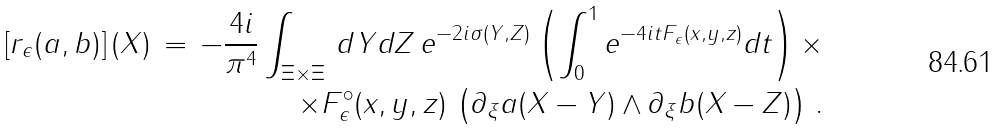Convert formula to latex. <formula><loc_0><loc_0><loc_500><loc_500>\left [ r _ { \epsilon } ( a , b ) \right ] ( X ) \, = \, - \frac { 4 i } { \pi ^ { 4 } } \int _ { \Xi \times \Xi } \, d Y d Z \, e ^ { - 2 i \sigma ( Y , Z ) } \left ( \int _ { 0 } ^ { 1 } e ^ { - 4 i t F _ { \epsilon } ( x , y , z ) } d t \right ) \times \\ \quad \times F ^ { \circ } _ { \epsilon } ( x , y , z ) \, \left ( \partial _ { \xi } a ( X - Y ) \wedge \partial _ { \xi } b ( X - Z ) \right ) \, .</formula> 